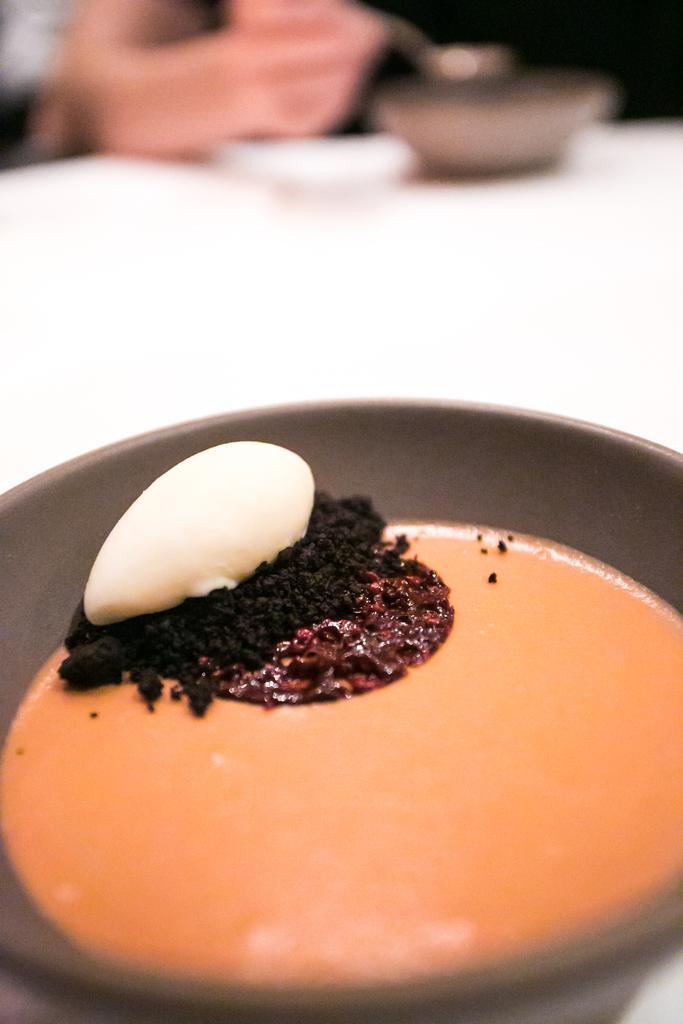How would you summarize this image in a sentence or two? In this image there is a table, on that table there is a bowl in that bowl there is food item, in the background it is blurred. 